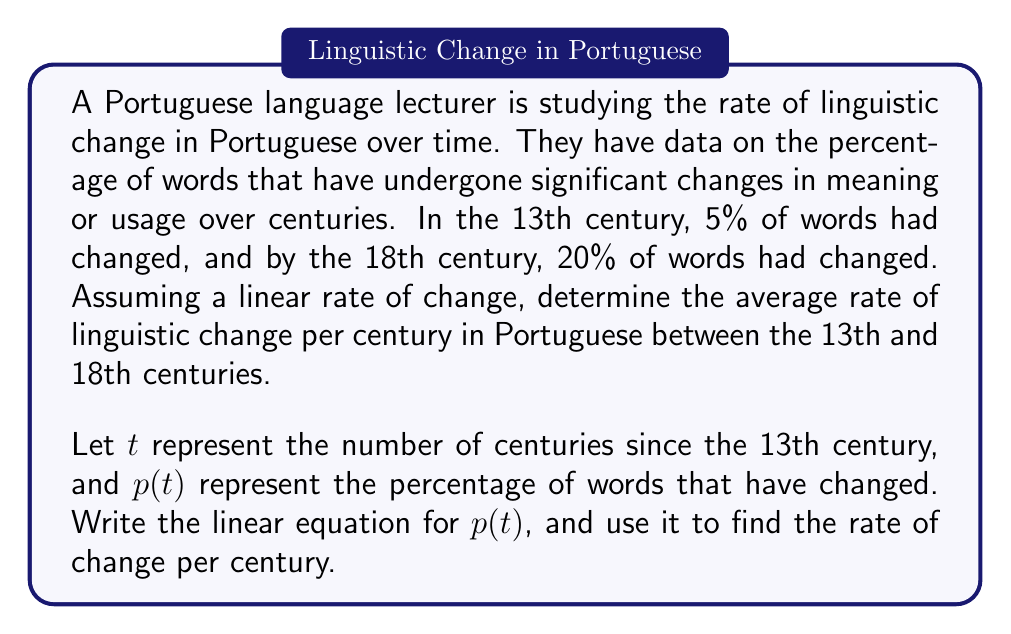Help me with this question. To solve this problem, we'll follow these steps:

1. Identify the given information:
   - At $t = 0$ (13th century), $p(0) = 5\%$
   - At $t = 5$ (18th century), $p(5) = 20\%$

2. Use the point-slope form of a linear equation:
   $p(t) - p(0) = m(t - 0)$, where $m$ is the slope (rate of change)

3. Calculate the slope $m$:
   $$m = \frac{p(5) - p(0)}{5 - 0} = \frac{20\% - 5\%}{5} = \frac{15\%}{5} = 3\%$$

4. Write the linear equation:
   $p(t) - 5\% = 3\%(t - 0)$
   $p(t) = 3\%t + 5\%$

5. Interpret the result:
   The slope $m = 3\%$ represents the rate of change per century.

Therefore, the average rate of linguistic change in Portuguese between the 13th and 18th centuries is 3% per century.
Answer: The average rate of linguistic change in Portuguese between the 13th and 18th centuries is 3% per century. The linear equation describing this change is $p(t) = 3\%t + 5\%$, where $t$ is the number of centuries since the 13th century and $p(t)$ is the percentage of words that have changed. 